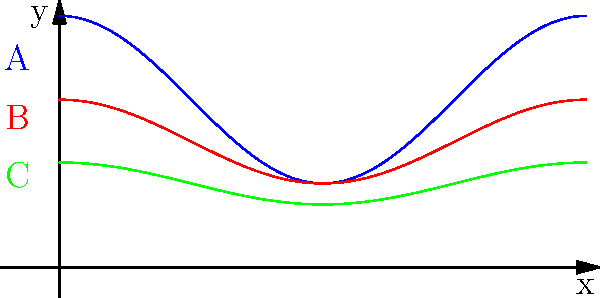The graph shows cross-sections of three arteries (A, B, and C) over a full cardiac cycle. Given that the ideal stent size should be 10% larger than the minimum artery diameter, which artery requires the largest stent? To determine which artery requires the largest stent, we need to follow these steps:

1. Identify the minimum diameter for each artery:
   A: $y_{min} = 1$
   B: $y_{min} = 1$
   C: $y_{min} = 0.75$

2. Calculate the ideal stent size for each artery (10% larger than the minimum):
   A: $1 \times 1.1 = 1.1$
   B: $1 \times 1.1 = 1.1$
   C: $0.75 \times 1.1 = 0.825$

3. Compare the calculated stent sizes:
   Artery A and B both require a stent of size 1.1, while artery C requires a smaller stent of size 0.825.

4. Identify the largest required stent size:
   The largest required stent size is 1.1, which is needed for both arteries A and B.

5. Choose between A and B:
   Since both A and B require the same stent size, we need to consider which one has the larger overall diameter range. Artery A has a larger amplitude in its oscillation, indicating a greater overall diameter range.

Therefore, artery A requires the largest stent.
Answer: A 